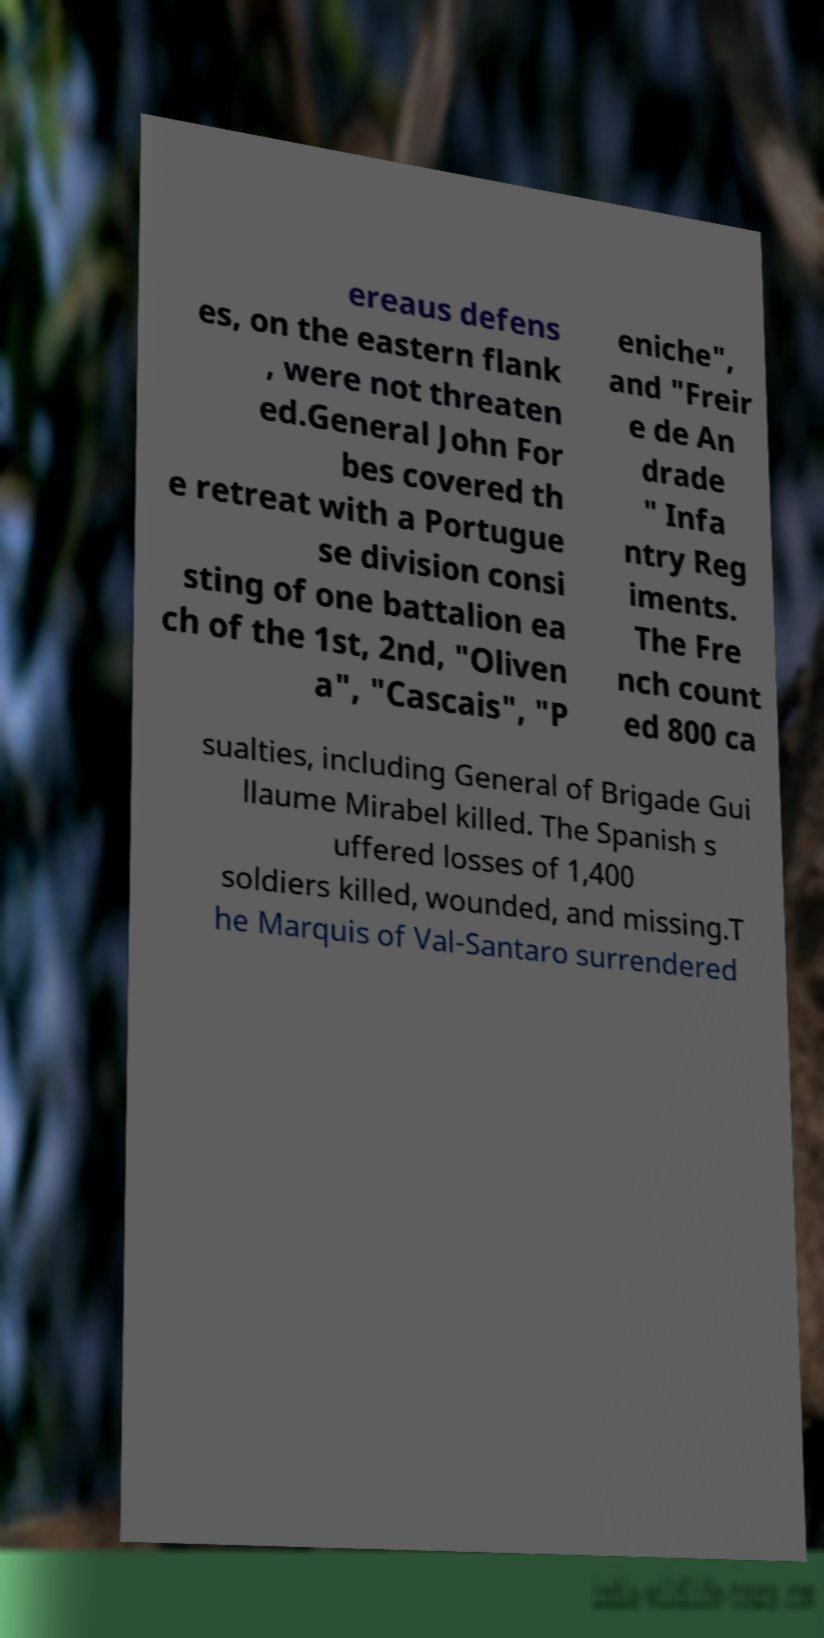There's text embedded in this image that I need extracted. Can you transcribe it verbatim? ereaus defens es, on the eastern flank , were not threaten ed.General John For bes covered th e retreat with a Portugue se division consi sting of one battalion ea ch of the 1st, 2nd, "Oliven a", "Cascais", "P eniche", and "Freir e de An drade " Infa ntry Reg iments. The Fre nch count ed 800 ca sualties, including General of Brigade Gui llaume Mirabel killed. The Spanish s uffered losses of 1,400 soldiers killed, wounded, and missing.T he Marquis of Val-Santaro surrendered 